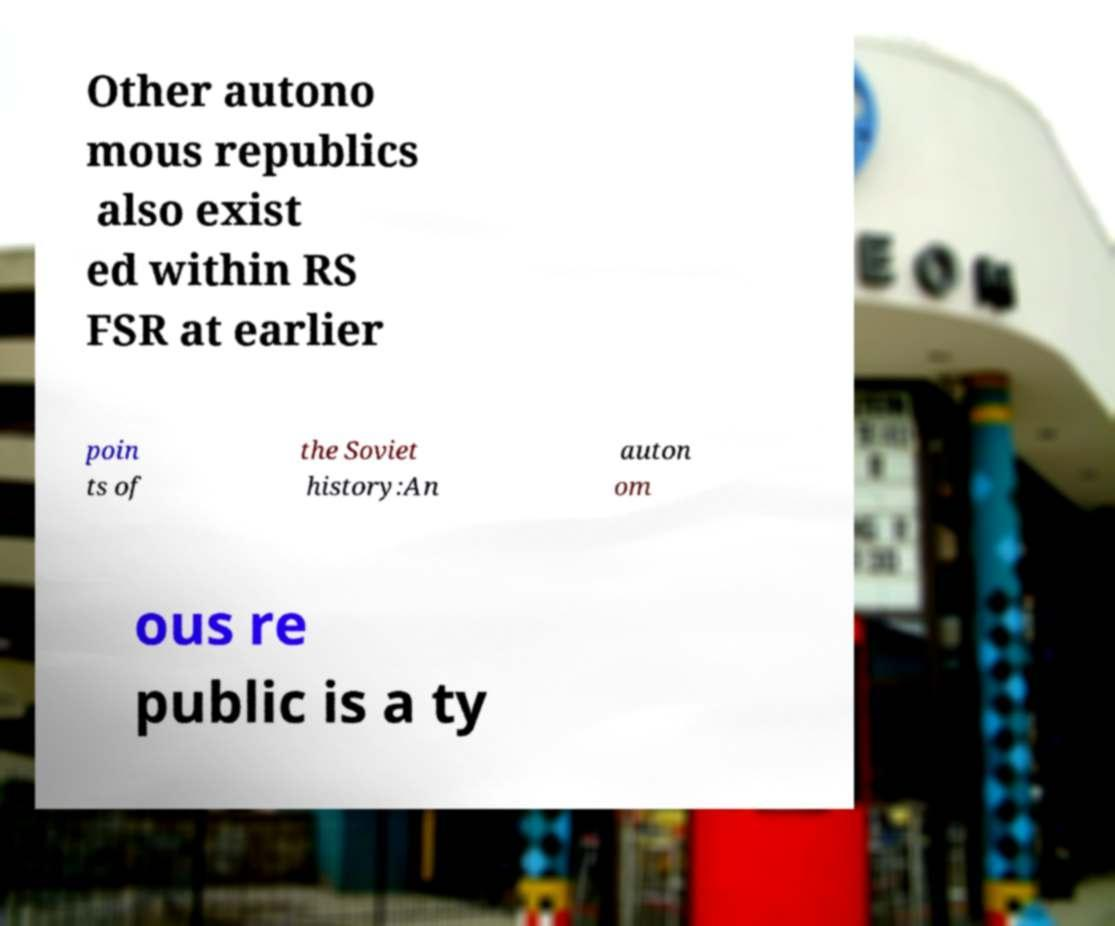Please identify and transcribe the text found in this image. Other autono mous republics also exist ed within RS FSR at earlier poin ts of the Soviet history:An auton om ous re public is a ty 